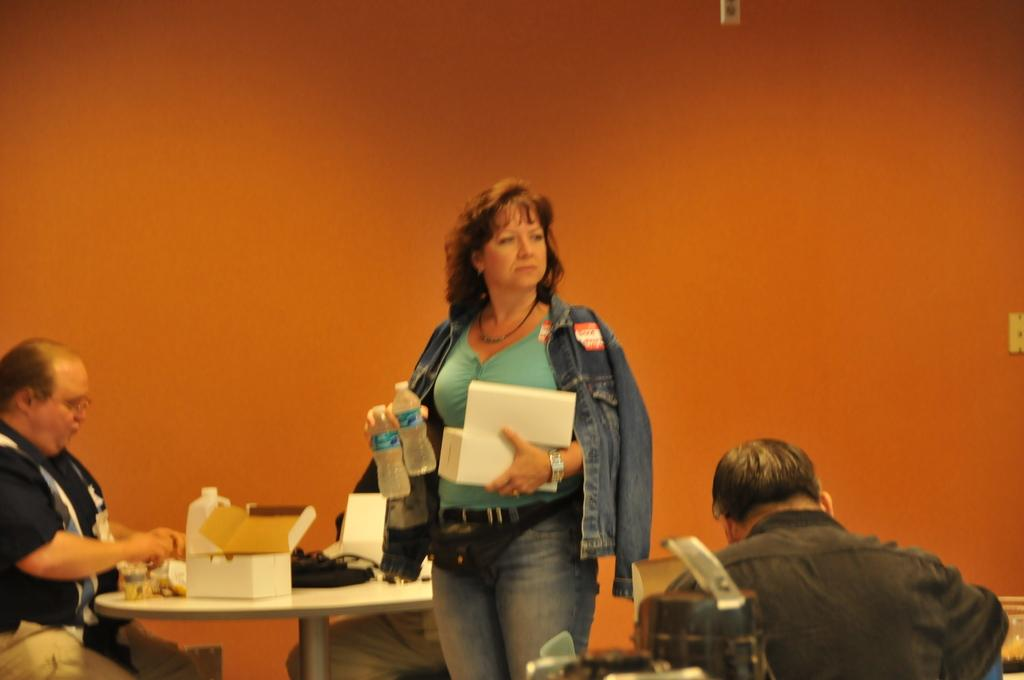How many people are in the image? There are people in the image, but the exact number is not specified. What is the woman holding in the image? The woman is standing and holding two bottles. What is present on the table in the image? There is a table in the image, and a box is on the table. Can you tell me how many bananas are in the box on the table? There is no information about bananas or any other specific items inside the box in the image. 